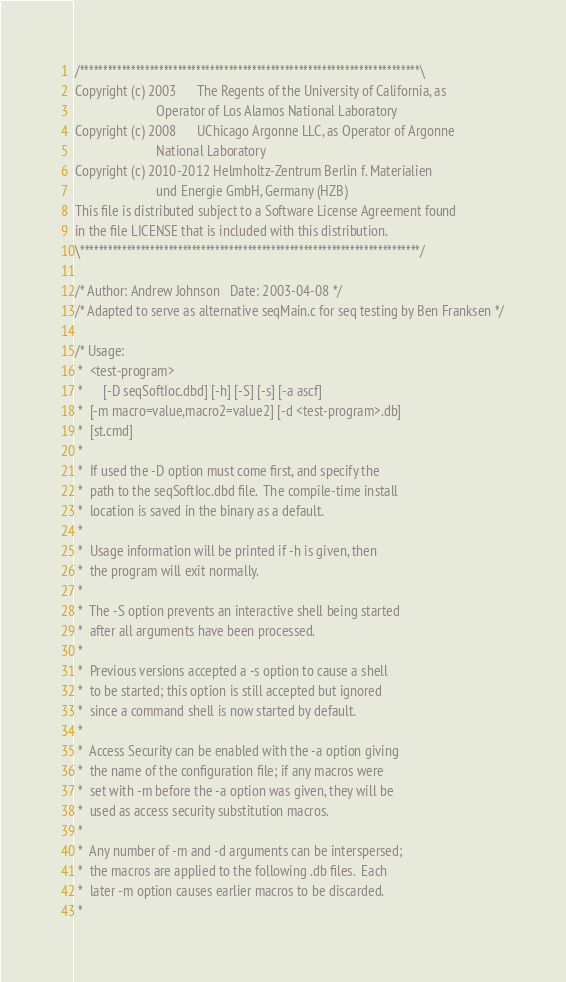<code> <loc_0><loc_0><loc_500><loc_500><_C_>/*************************************************************************\
Copyright (c) 2003      The Regents of the University of California, as
                        Operator of Los Alamos National Laboratory
Copyright (c) 2008      UChicago Argonne LLC, as Operator of Argonne
                        National Laboratory
Copyright (c) 2010-2012 Helmholtz-Zentrum Berlin f. Materialien
                        und Energie GmbH, Germany (HZB)
This file is distributed subject to a Software License Agreement found
in the file LICENSE that is included with this distribution.
\*************************************************************************/

/* Author: Andrew Johnson	Date: 2003-04-08 */
/* Adapted to serve as alternative seqMain.c for seq testing by Ben Franksen */

/* Usage:
 *  <test-program>
 *      [-D seqSoftIoc.dbd] [-h] [-S] [-s] [-a ascf]
 *	[-m macro=value,macro2=value2] [-d <test-program>.db]
 *	[st.cmd]
 *
 *  If used the -D option must come first, and specify the
 *  path to the seqSoftIoc.dbd file.  The compile-time install
 *  location is saved in the binary as a default.
 *
 *  Usage information will be printed if -h is given, then
 *  the program will exit normally.
 *
 *  The -S option prevents an interactive shell being started
 *  after all arguments have been processed.
 *
 *  Previous versions accepted a -s option to cause a shell
 *  to be started; this option is still accepted but ignored
 *  since a command shell is now started by default.
 *
 *  Access Security can be enabled with the -a option giving
 *  the name of the configuration file; if any macros were
 *  set with -m before the -a option was given, they will be
 *  used as access security substitution macros.
 *
 *  Any number of -m and -d arguments can be interspersed;
 *  the macros are applied to the following .db files.  Each
 *  later -m option causes earlier macros to be discarded.
 *</code> 